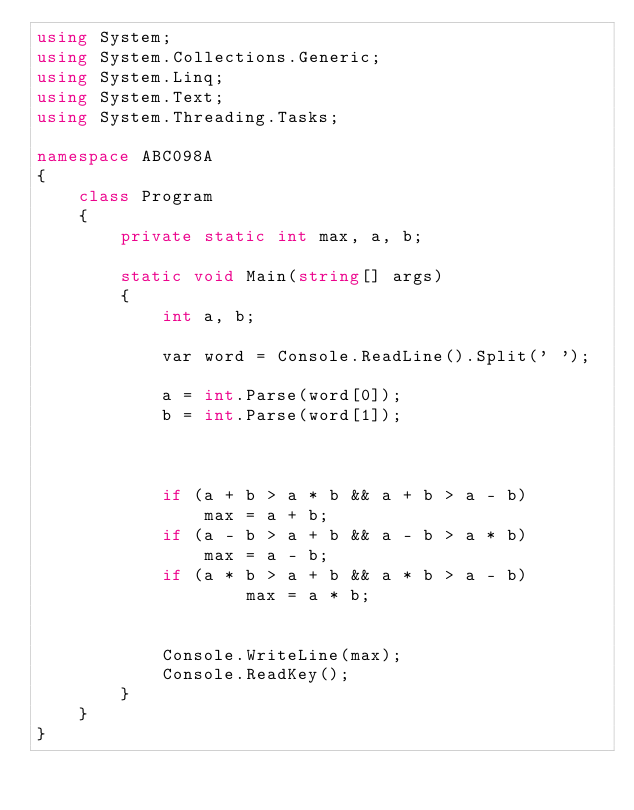Convert code to text. <code><loc_0><loc_0><loc_500><loc_500><_C#_>using System;
using System.Collections.Generic;
using System.Linq;
using System.Text;
using System.Threading.Tasks;

namespace ABC098A
{
    class Program
    {
        private static int max, a, b;

        static void Main(string[] args)
        {
            int a, b;

            var word = Console.ReadLine().Split(' ');

            a = int.Parse(word[0]);
            b = int.Parse(word[1]);


           
            if (a + b > a * b && a + b > a - b)
                max = a + b;
            if (a - b > a + b && a - b > a * b)
                max = a - b;
            if (a * b > a + b && a * b > a - b)
                    max = a * b;


            Console.WriteLine(max);
            Console.ReadKey();
        }
    }
}</code> 